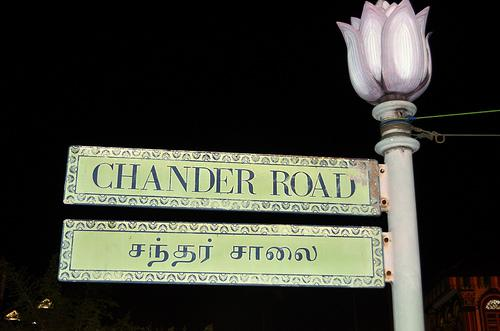Question: what does the English sign say?
Choices:
A. Stop.
B. Yield.
C. Chander Road.
D. 20 miles to Toronto.
Answer with the letter. Answer: C Question: where was this picture taken?
Choices:
A. In a cave.
B. On a hill.
C. Chander Road.
D. Under a tree.
Answer with the letter. Answer: C Question: when was this picture taken?
Choices:
A. After the wedding.
B. At my dad's wake.
C. When I was a baby.
D. Nighttime.
Answer with the letter. Answer: D Question: where is the English sign on the post?
Choices:
A. On the bottom.
B. In the middle.
C. At the top.
D. On the right side of the road.
Answer with the letter. Answer: C 